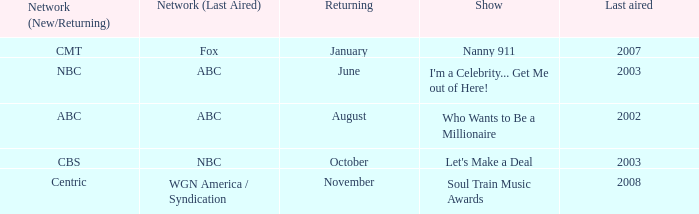When did a show last aired in 2002 return? August. 